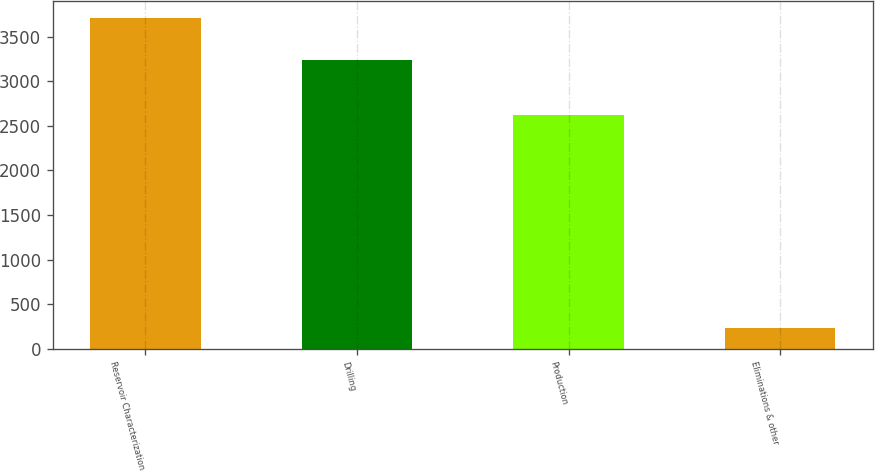Convert chart. <chart><loc_0><loc_0><loc_500><loc_500><bar_chart><fcel>Reservoir Characterization<fcel>Drilling<fcel>Production<fcel>Eliminations & other<nl><fcel>3711<fcel>3238<fcel>2624<fcel>229<nl></chart> 